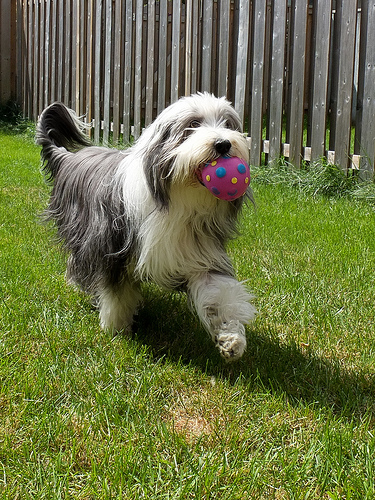<image>
Can you confirm if the ball is in the dog? Yes. The ball is contained within or inside the dog, showing a containment relationship. 